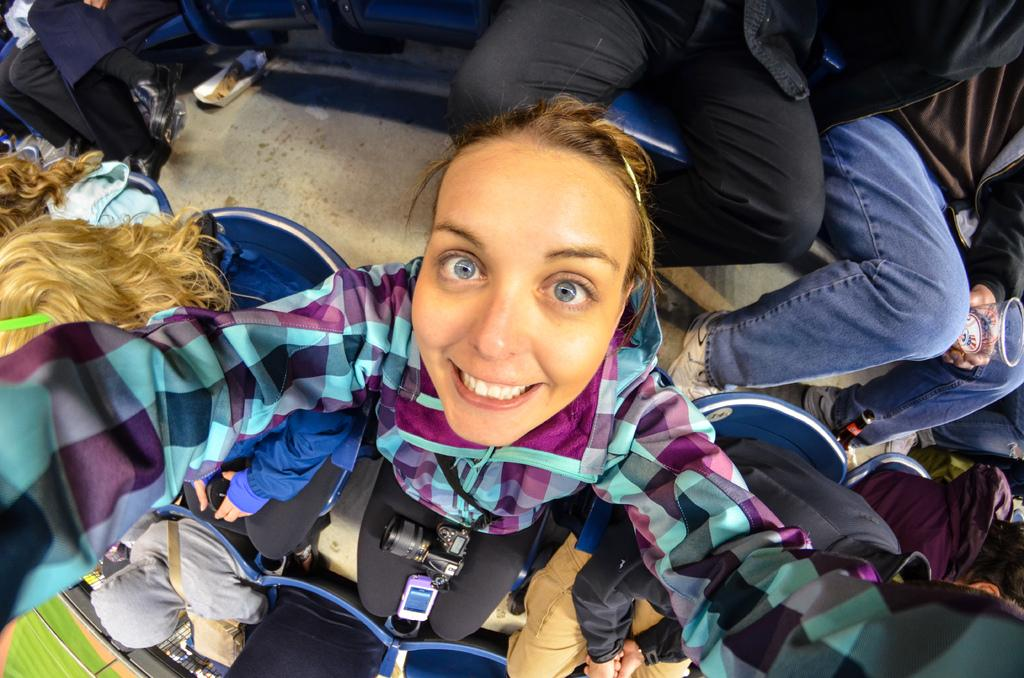Who is present in the image? There is a woman in the image. What is the woman wearing? The woman is wearing a shirt. What is the woman's facial expression? The woman is smiling. Can you describe the people sitting in the image? There are other persons sitting in the image. What can be seen in the background of the image? There is grass on the ground in the background of the image. How many ghosts are visible in the image? There are no ghosts present in the image. What type of vase can be seen on the table in the image? There is no vase present in the image. 